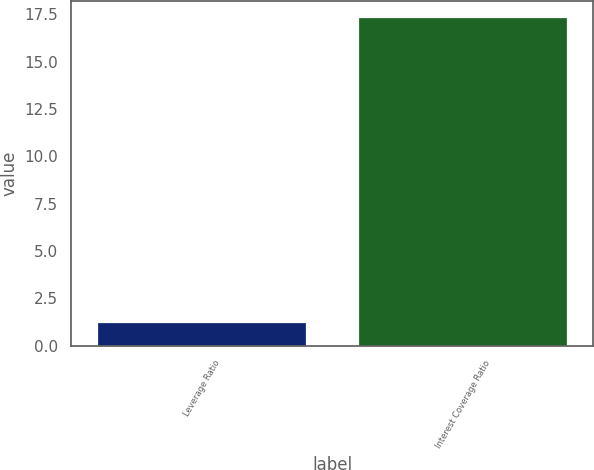<chart> <loc_0><loc_0><loc_500><loc_500><bar_chart><fcel>Leverage Ratio<fcel>Interest Coverage Ratio<nl><fcel>1.27<fcel>17.35<nl></chart> 